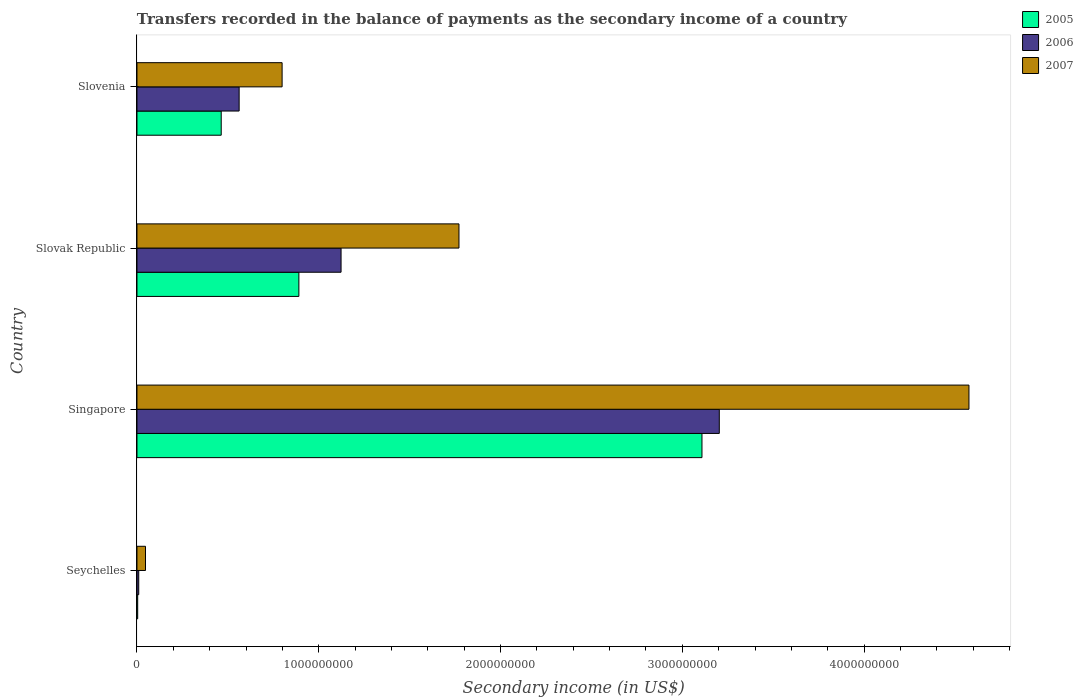How many different coloured bars are there?
Your response must be concise. 3. How many bars are there on the 4th tick from the top?
Offer a very short reply. 3. What is the label of the 2nd group of bars from the top?
Provide a succinct answer. Slovak Republic. What is the secondary income of in 2005 in Seychelles?
Your answer should be very brief. 3.99e+06. Across all countries, what is the maximum secondary income of in 2006?
Ensure brevity in your answer.  3.20e+09. Across all countries, what is the minimum secondary income of in 2007?
Ensure brevity in your answer.  4.69e+07. In which country was the secondary income of in 2007 maximum?
Keep it short and to the point. Singapore. In which country was the secondary income of in 2006 minimum?
Your answer should be very brief. Seychelles. What is the total secondary income of in 2007 in the graph?
Your answer should be very brief. 7.19e+09. What is the difference between the secondary income of in 2005 in Seychelles and that in Slovenia?
Keep it short and to the point. -4.60e+08. What is the difference between the secondary income of in 2007 in Slovak Republic and the secondary income of in 2006 in Singapore?
Your response must be concise. -1.43e+09. What is the average secondary income of in 2007 per country?
Make the answer very short. 1.80e+09. What is the difference between the secondary income of in 2006 and secondary income of in 2007 in Singapore?
Your answer should be very brief. -1.37e+09. What is the ratio of the secondary income of in 2006 in Seychelles to that in Singapore?
Your answer should be compact. 0. Is the secondary income of in 2006 in Seychelles less than that in Slovenia?
Your response must be concise. Yes. What is the difference between the highest and the second highest secondary income of in 2006?
Provide a succinct answer. 2.08e+09. What is the difference between the highest and the lowest secondary income of in 2006?
Your response must be concise. 3.19e+09. In how many countries, is the secondary income of in 2006 greater than the average secondary income of in 2006 taken over all countries?
Keep it short and to the point. 1. What does the 1st bar from the top in Singapore represents?
Provide a short and direct response. 2007. What does the 1st bar from the bottom in Singapore represents?
Offer a very short reply. 2005. Is it the case that in every country, the sum of the secondary income of in 2005 and secondary income of in 2007 is greater than the secondary income of in 2006?
Offer a terse response. Yes. How many countries are there in the graph?
Your response must be concise. 4. What is the difference between two consecutive major ticks on the X-axis?
Keep it short and to the point. 1.00e+09. Are the values on the major ticks of X-axis written in scientific E-notation?
Give a very brief answer. No. Does the graph contain any zero values?
Offer a very short reply. No. Where does the legend appear in the graph?
Your response must be concise. Top right. What is the title of the graph?
Your response must be concise. Transfers recorded in the balance of payments as the secondary income of a country. What is the label or title of the X-axis?
Offer a terse response. Secondary income (in US$). What is the Secondary income (in US$) in 2005 in Seychelles?
Provide a short and direct response. 3.99e+06. What is the Secondary income (in US$) of 2006 in Seychelles?
Provide a succinct answer. 9.75e+06. What is the Secondary income (in US$) of 2007 in Seychelles?
Your answer should be compact. 4.69e+07. What is the Secondary income (in US$) in 2005 in Singapore?
Ensure brevity in your answer.  3.11e+09. What is the Secondary income (in US$) in 2006 in Singapore?
Your answer should be very brief. 3.20e+09. What is the Secondary income (in US$) in 2007 in Singapore?
Provide a short and direct response. 4.58e+09. What is the Secondary income (in US$) in 2005 in Slovak Republic?
Your answer should be compact. 8.91e+08. What is the Secondary income (in US$) in 2006 in Slovak Republic?
Provide a succinct answer. 1.12e+09. What is the Secondary income (in US$) in 2007 in Slovak Republic?
Provide a succinct answer. 1.77e+09. What is the Secondary income (in US$) of 2005 in Slovenia?
Provide a short and direct response. 4.64e+08. What is the Secondary income (in US$) of 2006 in Slovenia?
Ensure brevity in your answer.  5.62e+08. What is the Secondary income (in US$) in 2007 in Slovenia?
Your answer should be very brief. 7.98e+08. Across all countries, what is the maximum Secondary income (in US$) in 2005?
Keep it short and to the point. 3.11e+09. Across all countries, what is the maximum Secondary income (in US$) in 2006?
Provide a succinct answer. 3.20e+09. Across all countries, what is the maximum Secondary income (in US$) in 2007?
Your answer should be very brief. 4.58e+09. Across all countries, what is the minimum Secondary income (in US$) of 2005?
Keep it short and to the point. 3.99e+06. Across all countries, what is the minimum Secondary income (in US$) in 2006?
Keep it short and to the point. 9.75e+06. Across all countries, what is the minimum Secondary income (in US$) in 2007?
Offer a terse response. 4.69e+07. What is the total Secondary income (in US$) of 2005 in the graph?
Give a very brief answer. 4.47e+09. What is the total Secondary income (in US$) of 2006 in the graph?
Provide a succinct answer. 4.90e+09. What is the total Secondary income (in US$) of 2007 in the graph?
Your response must be concise. 7.19e+09. What is the difference between the Secondary income (in US$) of 2005 in Seychelles and that in Singapore?
Provide a short and direct response. -3.10e+09. What is the difference between the Secondary income (in US$) in 2006 in Seychelles and that in Singapore?
Offer a very short reply. -3.19e+09. What is the difference between the Secondary income (in US$) of 2007 in Seychelles and that in Singapore?
Give a very brief answer. -4.53e+09. What is the difference between the Secondary income (in US$) in 2005 in Seychelles and that in Slovak Republic?
Make the answer very short. -8.87e+08. What is the difference between the Secondary income (in US$) in 2006 in Seychelles and that in Slovak Republic?
Offer a terse response. -1.11e+09. What is the difference between the Secondary income (in US$) in 2007 in Seychelles and that in Slovak Republic?
Give a very brief answer. -1.72e+09. What is the difference between the Secondary income (in US$) of 2005 in Seychelles and that in Slovenia?
Give a very brief answer. -4.60e+08. What is the difference between the Secondary income (in US$) of 2006 in Seychelles and that in Slovenia?
Your answer should be very brief. -5.52e+08. What is the difference between the Secondary income (in US$) of 2007 in Seychelles and that in Slovenia?
Keep it short and to the point. -7.51e+08. What is the difference between the Secondary income (in US$) of 2005 in Singapore and that in Slovak Republic?
Ensure brevity in your answer.  2.22e+09. What is the difference between the Secondary income (in US$) of 2006 in Singapore and that in Slovak Republic?
Your response must be concise. 2.08e+09. What is the difference between the Secondary income (in US$) of 2007 in Singapore and that in Slovak Republic?
Provide a succinct answer. 2.81e+09. What is the difference between the Secondary income (in US$) of 2005 in Singapore and that in Slovenia?
Give a very brief answer. 2.64e+09. What is the difference between the Secondary income (in US$) of 2006 in Singapore and that in Slovenia?
Provide a succinct answer. 2.64e+09. What is the difference between the Secondary income (in US$) in 2007 in Singapore and that in Slovenia?
Your answer should be compact. 3.78e+09. What is the difference between the Secondary income (in US$) in 2005 in Slovak Republic and that in Slovenia?
Make the answer very short. 4.27e+08. What is the difference between the Secondary income (in US$) in 2006 in Slovak Republic and that in Slovenia?
Your response must be concise. 5.61e+08. What is the difference between the Secondary income (in US$) of 2007 in Slovak Republic and that in Slovenia?
Your answer should be very brief. 9.73e+08. What is the difference between the Secondary income (in US$) in 2005 in Seychelles and the Secondary income (in US$) in 2006 in Singapore?
Your response must be concise. -3.20e+09. What is the difference between the Secondary income (in US$) in 2005 in Seychelles and the Secondary income (in US$) in 2007 in Singapore?
Offer a terse response. -4.57e+09. What is the difference between the Secondary income (in US$) in 2006 in Seychelles and the Secondary income (in US$) in 2007 in Singapore?
Give a very brief answer. -4.57e+09. What is the difference between the Secondary income (in US$) in 2005 in Seychelles and the Secondary income (in US$) in 2006 in Slovak Republic?
Ensure brevity in your answer.  -1.12e+09. What is the difference between the Secondary income (in US$) in 2005 in Seychelles and the Secondary income (in US$) in 2007 in Slovak Republic?
Keep it short and to the point. -1.77e+09. What is the difference between the Secondary income (in US$) of 2006 in Seychelles and the Secondary income (in US$) of 2007 in Slovak Republic?
Offer a terse response. -1.76e+09. What is the difference between the Secondary income (in US$) in 2005 in Seychelles and the Secondary income (in US$) in 2006 in Slovenia?
Your answer should be very brief. -5.58e+08. What is the difference between the Secondary income (in US$) of 2005 in Seychelles and the Secondary income (in US$) of 2007 in Slovenia?
Keep it short and to the point. -7.94e+08. What is the difference between the Secondary income (in US$) of 2006 in Seychelles and the Secondary income (in US$) of 2007 in Slovenia?
Your answer should be very brief. -7.89e+08. What is the difference between the Secondary income (in US$) in 2005 in Singapore and the Secondary income (in US$) in 2006 in Slovak Republic?
Keep it short and to the point. 1.99e+09. What is the difference between the Secondary income (in US$) in 2005 in Singapore and the Secondary income (in US$) in 2007 in Slovak Republic?
Ensure brevity in your answer.  1.34e+09. What is the difference between the Secondary income (in US$) in 2006 in Singapore and the Secondary income (in US$) in 2007 in Slovak Republic?
Provide a succinct answer. 1.43e+09. What is the difference between the Secondary income (in US$) of 2005 in Singapore and the Secondary income (in US$) of 2006 in Slovenia?
Your response must be concise. 2.55e+09. What is the difference between the Secondary income (in US$) in 2005 in Singapore and the Secondary income (in US$) in 2007 in Slovenia?
Your answer should be very brief. 2.31e+09. What is the difference between the Secondary income (in US$) in 2006 in Singapore and the Secondary income (in US$) in 2007 in Slovenia?
Offer a terse response. 2.40e+09. What is the difference between the Secondary income (in US$) in 2005 in Slovak Republic and the Secondary income (in US$) in 2006 in Slovenia?
Provide a short and direct response. 3.29e+08. What is the difference between the Secondary income (in US$) in 2005 in Slovak Republic and the Secondary income (in US$) in 2007 in Slovenia?
Make the answer very short. 9.23e+07. What is the difference between the Secondary income (in US$) in 2006 in Slovak Republic and the Secondary income (in US$) in 2007 in Slovenia?
Offer a terse response. 3.24e+08. What is the average Secondary income (in US$) of 2005 per country?
Give a very brief answer. 1.12e+09. What is the average Secondary income (in US$) of 2006 per country?
Your response must be concise. 1.22e+09. What is the average Secondary income (in US$) of 2007 per country?
Provide a succinct answer. 1.80e+09. What is the difference between the Secondary income (in US$) of 2005 and Secondary income (in US$) of 2006 in Seychelles?
Offer a terse response. -5.75e+06. What is the difference between the Secondary income (in US$) in 2005 and Secondary income (in US$) in 2007 in Seychelles?
Your answer should be compact. -4.29e+07. What is the difference between the Secondary income (in US$) in 2006 and Secondary income (in US$) in 2007 in Seychelles?
Your answer should be very brief. -3.72e+07. What is the difference between the Secondary income (in US$) in 2005 and Secondary income (in US$) in 2006 in Singapore?
Provide a short and direct response. -9.54e+07. What is the difference between the Secondary income (in US$) in 2005 and Secondary income (in US$) in 2007 in Singapore?
Your response must be concise. -1.47e+09. What is the difference between the Secondary income (in US$) in 2006 and Secondary income (in US$) in 2007 in Singapore?
Make the answer very short. -1.37e+09. What is the difference between the Secondary income (in US$) of 2005 and Secondary income (in US$) of 2006 in Slovak Republic?
Your answer should be compact. -2.32e+08. What is the difference between the Secondary income (in US$) of 2005 and Secondary income (in US$) of 2007 in Slovak Republic?
Offer a very short reply. -8.81e+08. What is the difference between the Secondary income (in US$) in 2006 and Secondary income (in US$) in 2007 in Slovak Republic?
Make the answer very short. -6.49e+08. What is the difference between the Secondary income (in US$) of 2005 and Secondary income (in US$) of 2006 in Slovenia?
Provide a short and direct response. -9.85e+07. What is the difference between the Secondary income (in US$) of 2005 and Secondary income (in US$) of 2007 in Slovenia?
Ensure brevity in your answer.  -3.35e+08. What is the difference between the Secondary income (in US$) of 2006 and Secondary income (in US$) of 2007 in Slovenia?
Offer a very short reply. -2.36e+08. What is the ratio of the Secondary income (in US$) in 2005 in Seychelles to that in Singapore?
Offer a very short reply. 0. What is the ratio of the Secondary income (in US$) of 2006 in Seychelles to that in Singapore?
Offer a terse response. 0. What is the ratio of the Secondary income (in US$) of 2007 in Seychelles to that in Singapore?
Keep it short and to the point. 0.01. What is the ratio of the Secondary income (in US$) in 2005 in Seychelles to that in Slovak Republic?
Provide a short and direct response. 0. What is the ratio of the Secondary income (in US$) in 2006 in Seychelles to that in Slovak Republic?
Your answer should be compact. 0.01. What is the ratio of the Secondary income (in US$) of 2007 in Seychelles to that in Slovak Republic?
Ensure brevity in your answer.  0.03. What is the ratio of the Secondary income (in US$) of 2005 in Seychelles to that in Slovenia?
Provide a short and direct response. 0.01. What is the ratio of the Secondary income (in US$) in 2006 in Seychelles to that in Slovenia?
Give a very brief answer. 0.02. What is the ratio of the Secondary income (in US$) in 2007 in Seychelles to that in Slovenia?
Provide a short and direct response. 0.06. What is the ratio of the Secondary income (in US$) in 2005 in Singapore to that in Slovak Republic?
Offer a very short reply. 3.49. What is the ratio of the Secondary income (in US$) of 2006 in Singapore to that in Slovak Republic?
Ensure brevity in your answer.  2.85. What is the ratio of the Secondary income (in US$) in 2007 in Singapore to that in Slovak Republic?
Keep it short and to the point. 2.58. What is the ratio of the Secondary income (in US$) in 2005 in Singapore to that in Slovenia?
Offer a terse response. 6.71. What is the ratio of the Secondary income (in US$) of 2006 in Singapore to that in Slovenia?
Your response must be concise. 5.7. What is the ratio of the Secondary income (in US$) of 2007 in Singapore to that in Slovenia?
Provide a succinct answer. 5.73. What is the ratio of the Secondary income (in US$) in 2005 in Slovak Republic to that in Slovenia?
Offer a very short reply. 1.92. What is the ratio of the Secondary income (in US$) in 2006 in Slovak Republic to that in Slovenia?
Ensure brevity in your answer.  2. What is the ratio of the Secondary income (in US$) in 2007 in Slovak Republic to that in Slovenia?
Offer a very short reply. 2.22. What is the difference between the highest and the second highest Secondary income (in US$) of 2005?
Offer a terse response. 2.22e+09. What is the difference between the highest and the second highest Secondary income (in US$) of 2006?
Make the answer very short. 2.08e+09. What is the difference between the highest and the second highest Secondary income (in US$) of 2007?
Your answer should be compact. 2.81e+09. What is the difference between the highest and the lowest Secondary income (in US$) in 2005?
Keep it short and to the point. 3.10e+09. What is the difference between the highest and the lowest Secondary income (in US$) of 2006?
Give a very brief answer. 3.19e+09. What is the difference between the highest and the lowest Secondary income (in US$) in 2007?
Keep it short and to the point. 4.53e+09. 